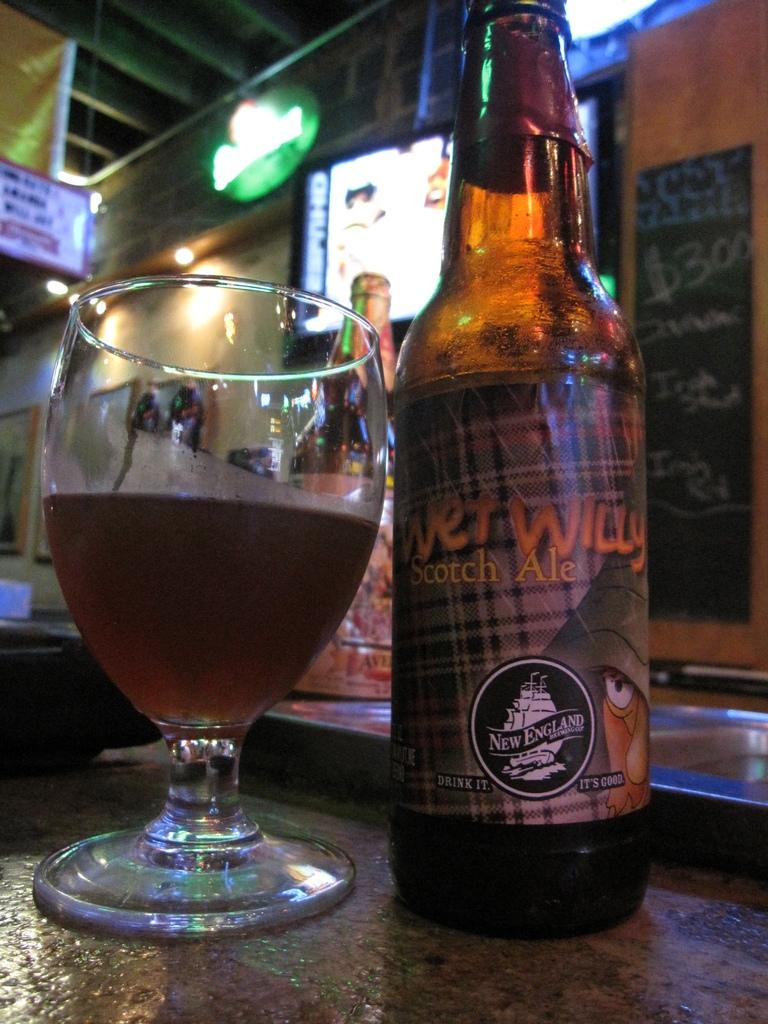What is inside of this bottle?
Ensure brevity in your answer.  Scotch ale. 